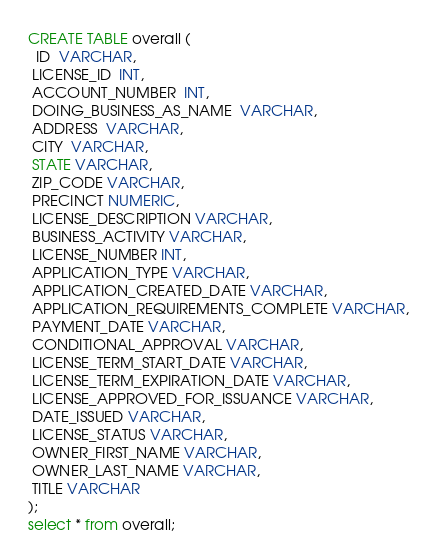<code> <loc_0><loc_0><loc_500><loc_500><_SQL_>CREATE TABLE overall (
  ID  VARCHAR,
 LICENSE_ID  INT,
 ACCOUNT_NUMBER  INT,
 DOING_BUSINESS_AS_NAME  VARCHAR,
 ADDRESS  VARCHAR,
 CITY  VARCHAR,
 STATE VARCHAR,
 ZIP_CODE VARCHAR,
 PRECINCT NUMERIC,
 LICENSE_DESCRIPTION VARCHAR,
 BUSINESS_ACTIVITY VARCHAR,
 LICENSE_NUMBER INT,
 APPLICATION_TYPE VARCHAR,
 APPLICATION_CREATED_DATE VARCHAR,
 APPLICATION_REQUIREMENTS_COMPLETE VARCHAR,
 PAYMENT_DATE VARCHAR,
 CONDITIONAL_APPROVAL VARCHAR,
 LICENSE_TERM_START_DATE VARCHAR,
 LICENSE_TERM_EXPIRATION_DATE VARCHAR,
 LICENSE_APPROVED_FOR_ISSUANCE VARCHAR,
 DATE_ISSUED VARCHAR,
 LICENSE_STATUS VARCHAR,
 OWNER_FIRST_NAME VARCHAR,
 OWNER_LAST_NAME VARCHAR,
 TITLE VARCHAR
);
select * from overall;
















</code> 